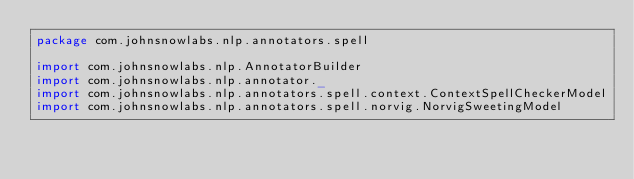<code> <loc_0><loc_0><loc_500><loc_500><_Scala_>package com.johnsnowlabs.nlp.annotators.spell

import com.johnsnowlabs.nlp.AnnotatorBuilder
import com.johnsnowlabs.nlp.annotator._
import com.johnsnowlabs.nlp.annotators.spell.context.ContextSpellCheckerModel
import com.johnsnowlabs.nlp.annotators.spell.norvig.NorvigSweetingModel</code> 